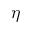<formula> <loc_0><loc_0><loc_500><loc_500>\eta</formula> 